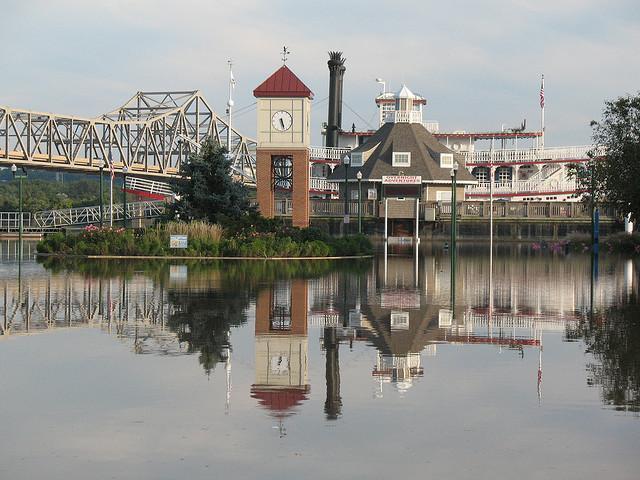How many boats do you see?
Give a very brief answer. 0. How many cats have a banana in their paws?
Give a very brief answer. 0. 